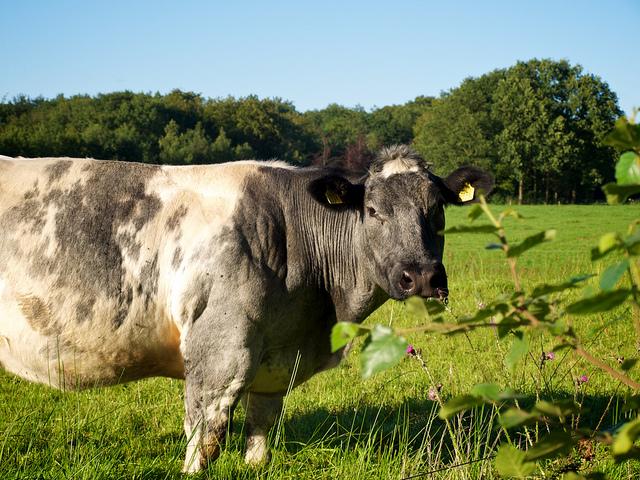What is this animal?
Be succinct. Cow. Is there a house in the picture?
Short answer required. No. What color are the animals?
Short answer required. Black and white. What color is this animal?
Write a very short answer. Black and white. 